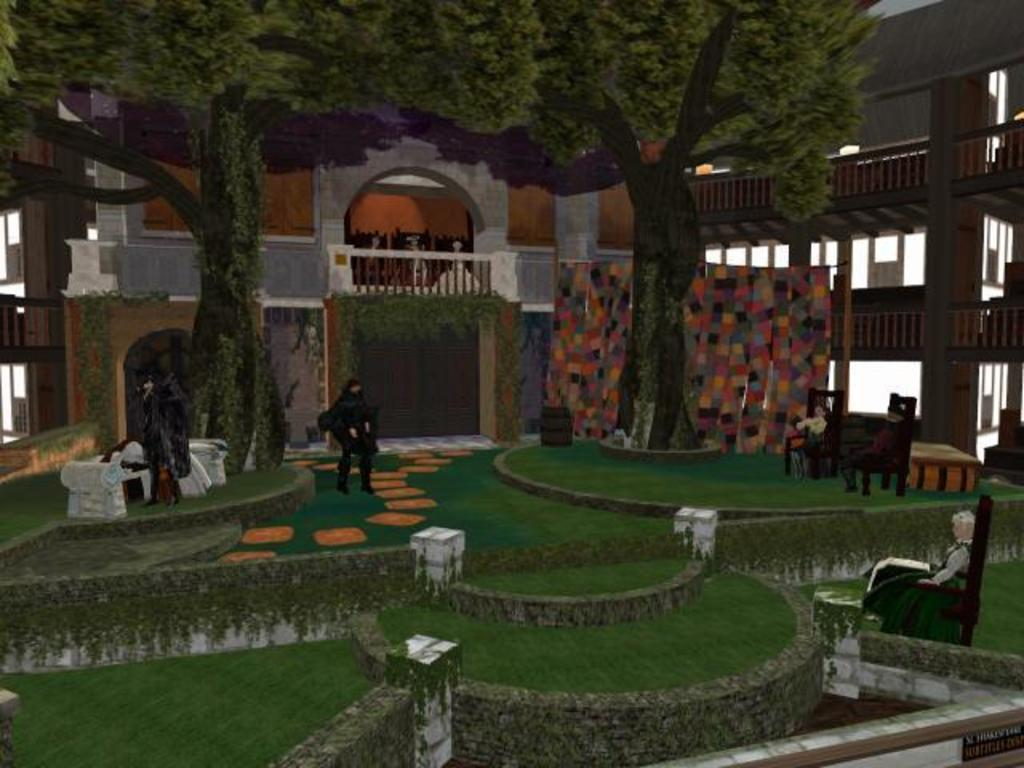What type of vegetation can be seen in the image? There are trees in the image. What type of seating is visible in the image? There are chairs in the image. Who or what is present in the image? There are persons in the image. What type of structure can be seen in the image? There are walls in the image. What type of ground surface is visible in the image? There is grass in the image. What is visible in the background of the image? There is a building in the background of the image. What is the purpose of the cherry in the image? There is no cherry present in the image, so it is not possible to determine its purpose. How does the size of the persons in the image compare to the size of the building in the background? The size of the persons in the image cannot be compared to the size of the building in the background, as the image does not provide any information about the relative sizes of these elements. 